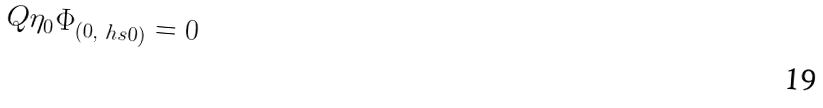<formula> <loc_0><loc_0><loc_500><loc_500>Q \eta _ { 0 } \Phi _ { ( 0 , \ h s 0 ) } = 0</formula> 